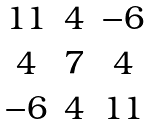<formula> <loc_0><loc_0><loc_500><loc_500>\begin{matrix} 1 1 & 4 & - 6 \\ 4 & 7 & 4 \\ - 6 & 4 & 1 1 \end{matrix}</formula> 